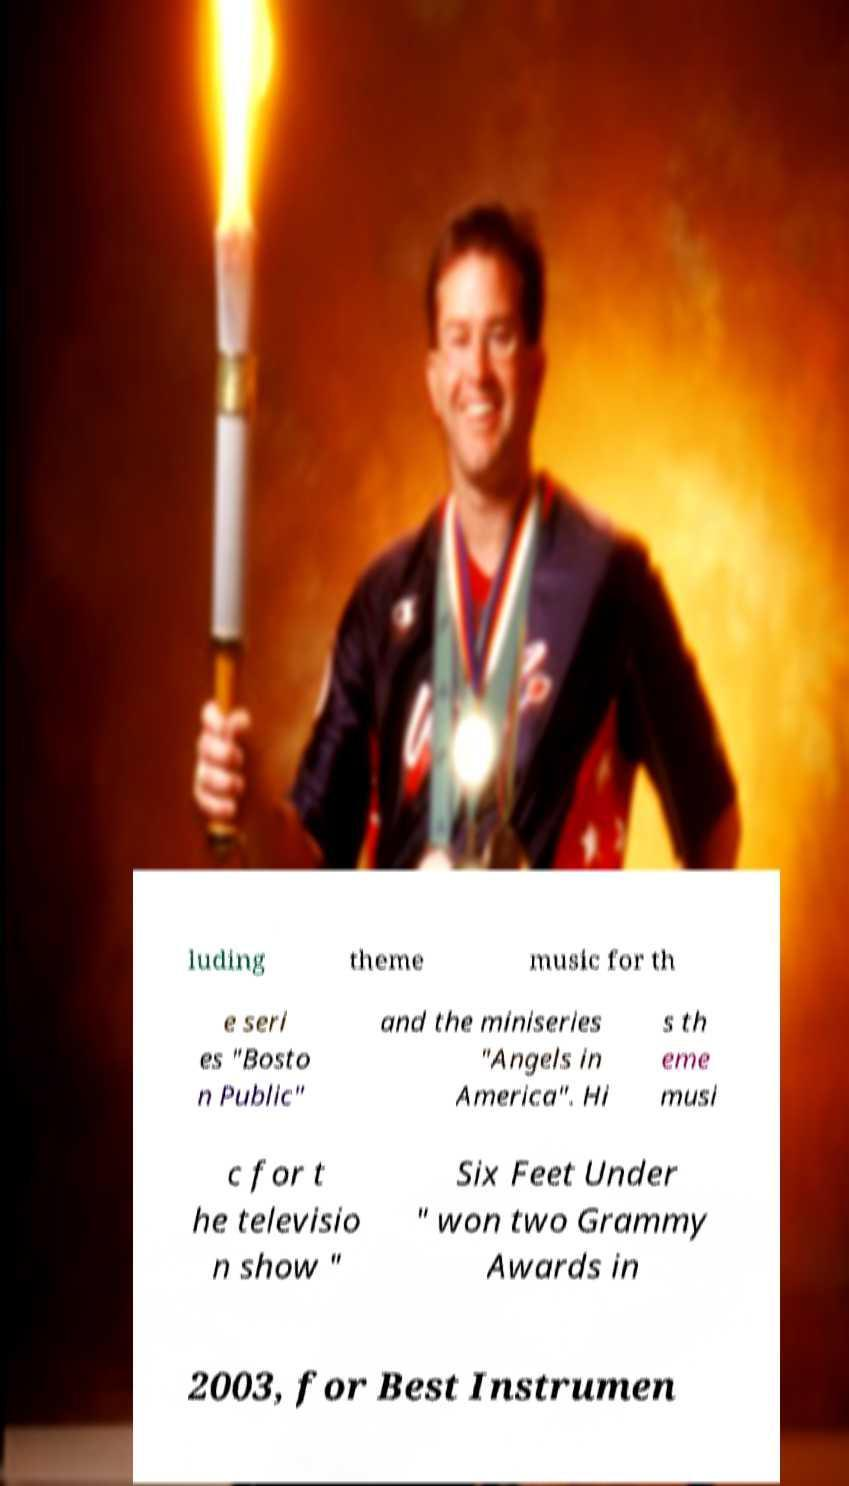Can you read and provide the text displayed in the image?This photo seems to have some interesting text. Can you extract and type it out for me? luding theme music for th e seri es "Bosto n Public" and the miniseries "Angels in America". Hi s th eme musi c for t he televisio n show " Six Feet Under " won two Grammy Awards in 2003, for Best Instrumen 